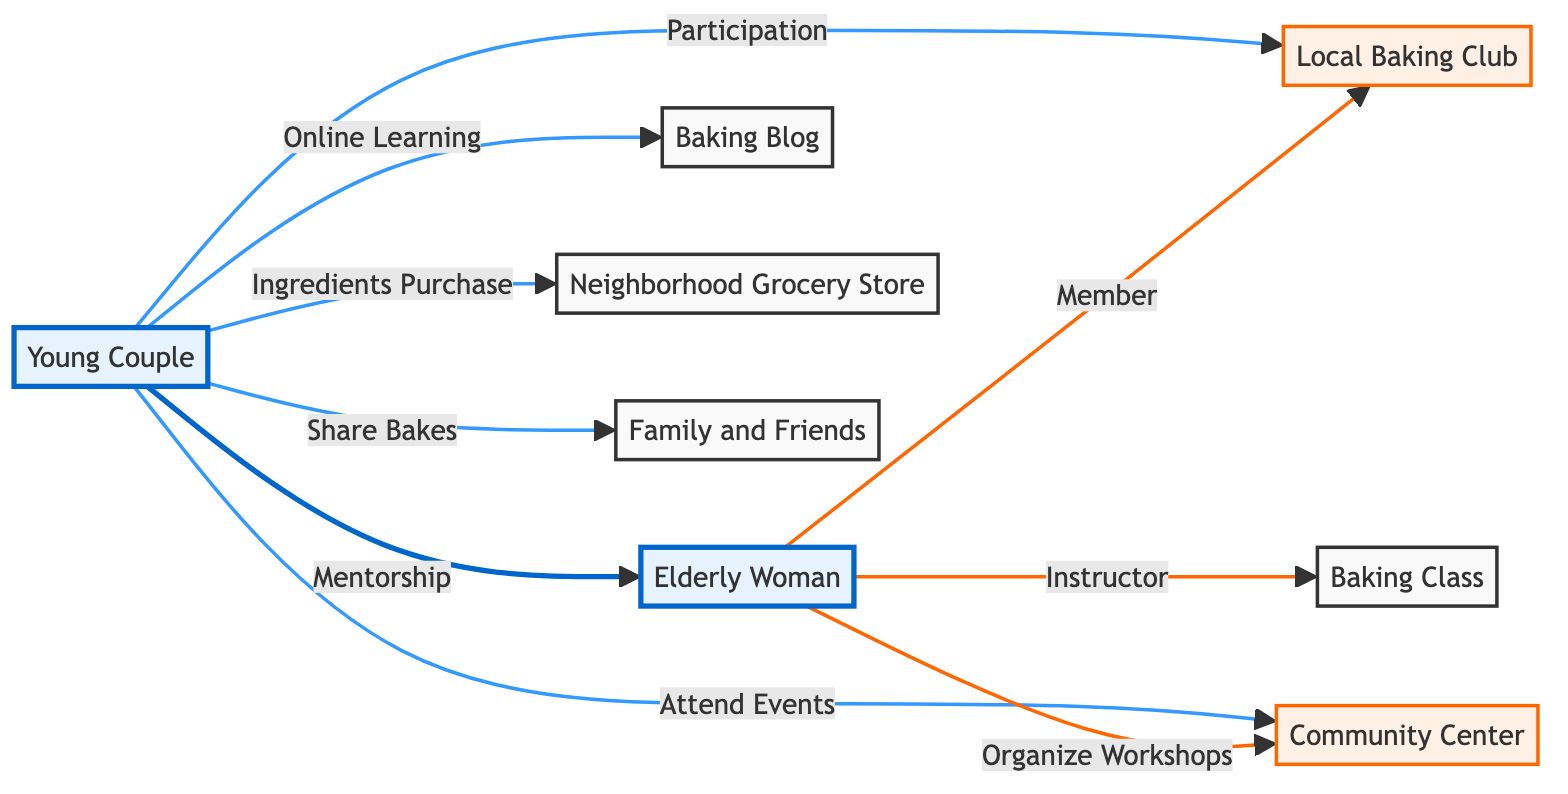What is the total number of nodes in the diagram? The diagram contains a list of nodes, which are Young Couple, Elderly Woman, Local Baking Club, Baking Blog, Neighborhood Grocery Store, Community Center, Baking Class, and Family and Friends. Counting these, there are 8 nodes in total.
Answer: 8 How many edges connect the Young Couple and the Elderly Woman? There is one edge connecting the Young Couple to the Elderly Woman labeled as "Mentorship". Thus, the total number of edges connecting them is one.
Answer: 1 What type of relationship exists between the elderly woman and the baking class? The diagram indicates that the elderly woman is connected to the baking class with an edge labeled "Instructor". This signifies she plays the role of an instructor in the baking class.
Answer: Instructor Which node represents a source for purchasing ingredients? The node labeled "Neighborhood Grocery Store" is indicated as a source for purchasing ingredients, showing the relationship with the Young Couple.
Answer: Neighborhood Grocery Store How many connections does the elderly woman have? The elderly woman has three connections: one to the Local Baking Club (Member), one to the Baking Class (Instructor), and one to the Community Center (Organize Workshops). In total, she has three connections.
Answer: 3 Is the Young Couple involved in any baking classes, and if yes, how? The Young Couple is connected to the Elderly Woman, who is the instructor of the Baking Class. This implies that they are indirectly involved in baking classes through her instruction.
Answer: Yes, through the Elderly Woman Which node has the label "Share Bakes"? The Young Couple is linked to the Family and Friends with an edge labeled "Share Bakes", indicating they share their baking efforts with their family and friends.
Answer: Family and Friends What is the role of the elderly woman in the Local Baking Club? The elder woman has a connection to the Local Baking Club labeled as "Member", which indicates her participation status in that club.
Answer: Member How do the Young Couple and the Community Center interact? The Young Couple is connected to the Community Center with an edge labeled "Attend Events", showing their interaction through attending events at that location.
Answer: Attend Events What can we infer about the Young Couple's involvement in learning baking skills? The Young Couple is connected to multiple sources including the Elderly Woman (Mentorship), Baking Blog (Online Learning), and Local Baking Club (Participation), indicating a multifaceted approach to learning baking skills.
Answer: Multifaceted approach 